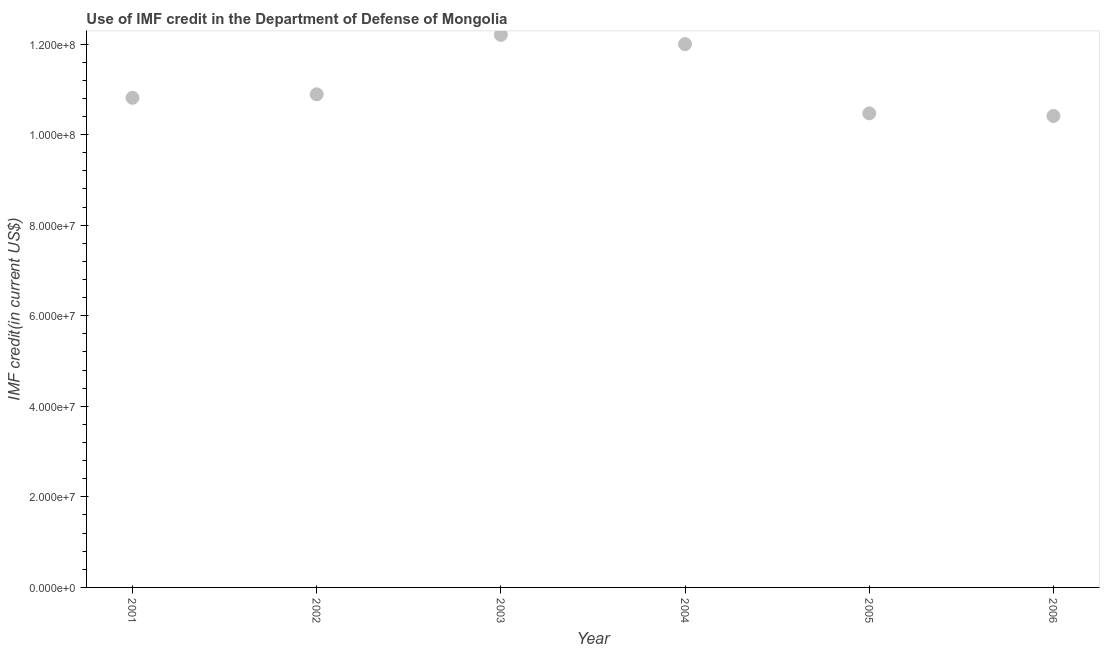What is the use of imf credit in dod in 2001?
Make the answer very short. 1.08e+08. Across all years, what is the maximum use of imf credit in dod?
Keep it short and to the point. 1.22e+08. Across all years, what is the minimum use of imf credit in dod?
Make the answer very short. 1.04e+08. What is the sum of the use of imf credit in dod?
Provide a succinct answer. 6.68e+08. What is the difference between the use of imf credit in dod in 2002 and 2003?
Your response must be concise. -1.31e+07. What is the average use of imf credit in dod per year?
Make the answer very short. 1.11e+08. What is the median use of imf credit in dod?
Provide a short and direct response. 1.09e+08. What is the ratio of the use of imf credit in dod in 2002 to that in 2004?
Make the answer very short. 0.91. Is the use of imf credit in dod in 2002 less than that in 2003?
Ensure brevity in your answer.  Yes. Is the difference between the use of imf credit in dod in 2002 and 2006 greater than the difference between any two years?
Offer a very short reply. No. What is the difference between the highest and the second highest use of imf credit in dod?
Make the answer very short. 2.04e+06. What is the difference between the highest and the lowest use of imf credit in dod?
Offer a terse response. 1.79e+07. In how many years, is the use of imf credit in dod greater than the average use of imf credit in dod taken over all years?
Offer a terse response. 2. What is the difference between two consecutive major ticks on the Y-axis?
Offer a terse response. 2.00e+07. Are the values on the major ticks of Y-axis written in scientific E-notation?
Make the answer very short. Yes. Does the graph contain grids?
Ensure brevity in your answer.  No. What is the title of the graph?
Keep it short and to the point. Use of IMF credit in the Department of Defense of Mongolia. What is the label or title of the Y-axis?
Provide a succinct answer. IMF credit(in current US$). What is the IMF credit(in current US$) in 2001?
Make the answer very short. 1.08e+08. What is the IMF credit(in current US$) in 2002?
Your response must be concise. 1.09e+08. What is the IMF credit(in current US$) in 2003?
Offer a very short reply. 1.22e+08. What is the IMF credit(in current US$) in 2004?
Your response must be concise. 1.20e+08. What is the IMF credit(in current US$) in 2005?
Your answer should be compact. 1.05e+08. What is the IMF credit(in current US$) in 2006?
Your answer should be very brief. 1.04e+08. What is the difference between the IMF credit(in current US$) in 2001 and 2002?
Your answer should be compact. -7.73e+05. What is the difference between the IMF credit(in current US$) in 2001 and 2003?
Your response must be concise. -1.39e+07. What is the difference between the IMF credit(in current US$) in 2001 and 2004?
Provide a short and direct response. -1.19e+07. What is the difference between the IMF credit(in current US$) in 2001 and 2005?
Your answer should be very brief. 3.43e+06. What is the difference between the IMF credit(in current US$) in 2001 and 2006?
Ensure brevity in your answer.  4.01e+06. What is the difference between the IMF credit(in current US$) in 2002 and 2003?
Offer a very short reply. -1.31e+07. What is the difference between the IMF credit(in current US$) in 2002 and 2004?
Your response must be concise. -1.11e+07. What is the difference between the IMF credit(in current US$) in 2002 and 2005?
Give a very brief answer. 4.20e+06. What is the difference between the IMF credit(in current US$) in 2002 and 2006?
Offer a very short reply. 4.78e+06. What is the difference between the IMF credit(in current US$) in 2003 and 2004?
Offer a terse response. 2.04e+06. What is the difference between the IMF credit(in current US$) in 2003 and 2005?
Ensure brevity in your answer.  1.73e+07. What is the difference between the IMF credit(in current US$) in 2003 and 2006?
Make the answer very short. 1.79e+07. What is the difference between the IMF credit(in current US$) in 2004 and 2005?
Your answer should be very brief. 1.53e+07. What is the difference between the IMF credit(in current US$) in 2004 and 2006?
Keep it short and to the point. 1.59e+07. What is the difference between the IMF credit(in current US$) in 2005 and 2006?
Give a very brief answer. 5.81e+05. What is the ratio of the IMF credit(in current US$) in 2001 to that in 2003?
Ensure brevity in your answer.  0.89. What is the ratio of the IMF credit(in current US$) in 2001 to that in 2004?
Your answer should be compact. 0.9. What is the ratio of the IMF credit(in current US$) in 2001 to that in 2005?
Your answer should be compact. 1.03. What is the ratio of the IMF credit(in current US$) in 2001 to that in 2006?
Your answer should be compact. 1.04. What is the ratio of the IMF credit(in current US$) in 2002 to that in 2003?
Ensure brevity in your answer.  0.89. What is the ratio of the IMF credit(in current US$) in 2002 to that in 2004?
Keep it short and to the point. 0.91. What is the ratio of the IMF credit(in current US$) in 2002 to that in 2005?
Ensure brevity in your answer.  1.04. What is the ratio of the IMF credit(in current US$) in 2002 to that in 2006?
Ensure brevity in your answer.  1.05. What is the ratio of the IMF credit(in current US$) in 2003 to that in 2005?
Provide a short and direct response. 1.17. What is the ratio of the IMF credit(in current US$) in 2003 to that in 2006?
Provide a short and direct response. 1.17. What is the ratio of the IMF credit(in current US$) in 2004 to that in 2005?
Make the answer very short. 1.15. What is the ratio of the IMF credit(in current US$) in 2004 to that in 2006?
Make the answer very short. 1.15. 